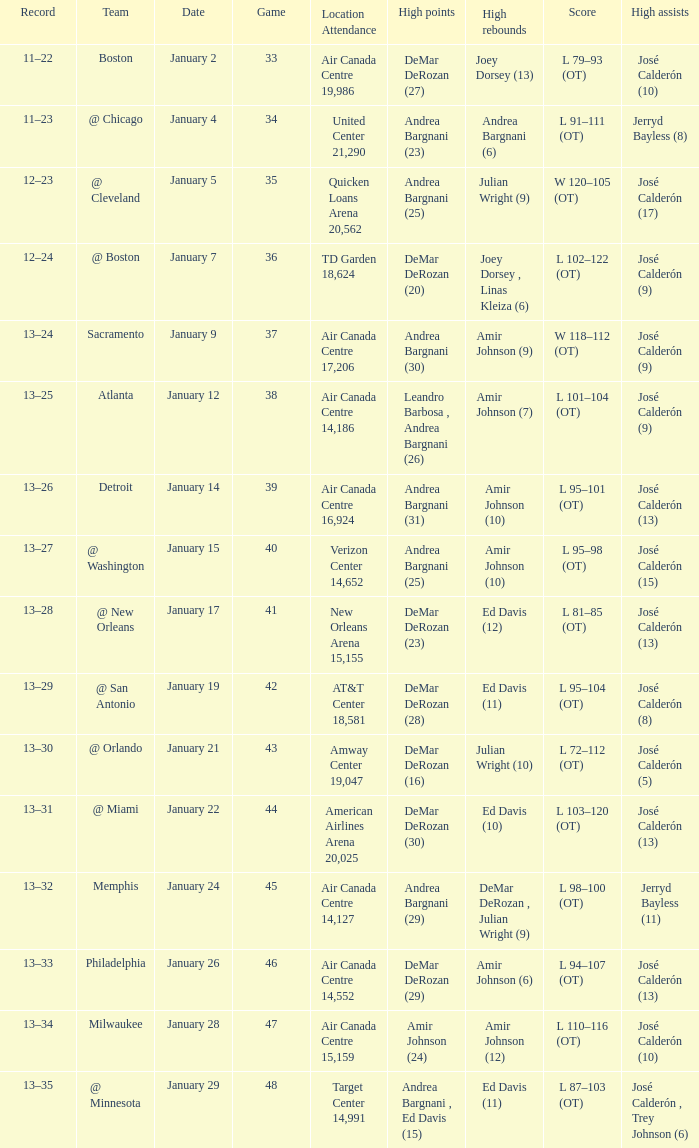Name the number of high rebounds for january 5 1.0. 